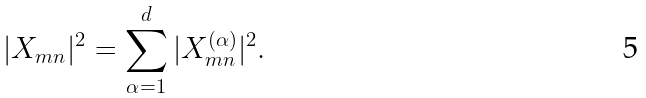<formula> <loc_0><loc_0><loc_500><loc_500>| X _ { m n } | ^ { 2 } = \sum _ { \alpha = 1 } ^ { d } | X _ { m n } ^ { ( \alpha ) } | ^ { 2 } .</formula> 